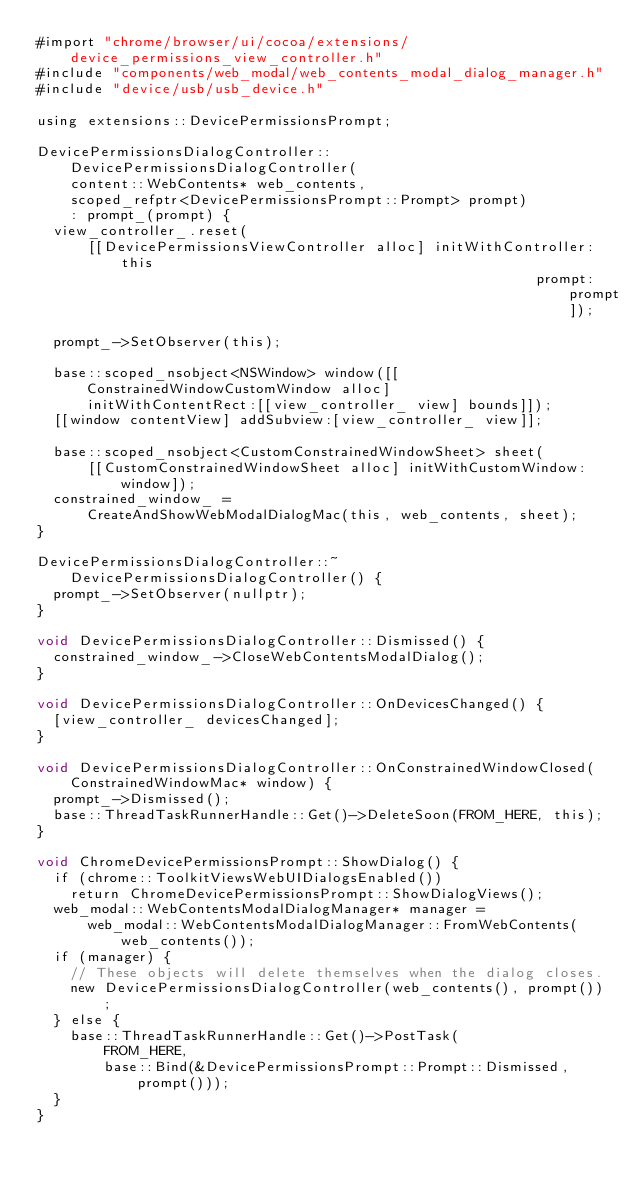Convert code to text. <code><loc_0><loc_0><loc_500><loc_500><_ObjectiveC_>#import "chrome/browser/ui/cocoa/extensions/device_permissions_view_controller.h"
#include "components/web_modal/web_contents_modal_dialog_manager.h"
#include "device/usb/usb_device.h"

using extensions::DevicePermissionsPrompt;

DevicePermissionsDialogController::DevicePermissionsDialogController(
    content::WebContents* web_contents,
    scoped_refptr<DevicePermissionsPrompt::Prompt> prompt)
    : prompt_(prompt) {
  view_controller_.reset(
      [[DevicePermissionsViewController alloc] initWithController:this
                                                           prompt:prompt]);

  prompt_->SetObserver(this);

  base::scoped_nsobject<NSWindow> window([[ConstrainedWindowCustomWindow alloc]
      initWithContentRect:[[view_controller_ view] bounds]]);
  [[window contentView] addSubview:[view_controller_ view]];

  base::scoped_nsobject<CustomConstrainedWindowSheet> sheet(
      [[CustomConstrainedWindowSheet alloc] initWithCustomWindow:window]);
  constrained_window_ =
      CreateAndShowWebModalDialogMac(this, web_contents, sheet);
}

DevicePermissionsDialogController::~DevicePermissionsDialogController() {
  prompt_->SetObserver(nullptr);
}

void DevicePermissionsDialogController::Dismissed() {
  constrained_window_->CloseWebContentsModalDialog();
}

void DevicePermissionsDialogController::OnDevicesChanged() {
  [view_controller_ devicesChanged];
}

void DevicePermissionsDialogController::OnConstrainedWindowClosed(
    ConstrainedWindowMac* window) {
  prompt_->Dismissed();
  base::ThreadTaskRunnerHandle::Get()->DeleteSoon(FROM_HERE, this);
}

void ChromeDevicePermissionsPrompt::ShowDialog() {
  if (chrome::ToolkitViewsWebUIDialogsEnabled())
    return ChromeDevicePermissionsPrompt::ShowDialogViews();
  web_modal::WebContentsModalDialogManager* manager =
      web_modal::WebContentsModalDialogManager::FromWebContents(web_contents());
  if (manager) {
    // These objects will delete themselves when the dialog closes.
    new DevicePermissionsDialogController(web_contents(), prompt());
  } else {
    base::ThreadTaskRunnerHandle::Get()->PostTask(
        FROM_HERE,
        base::Bind(&DevicePermissionsPrompt::Prompt::Dismissed, prompt()));
  }
}
</code> 